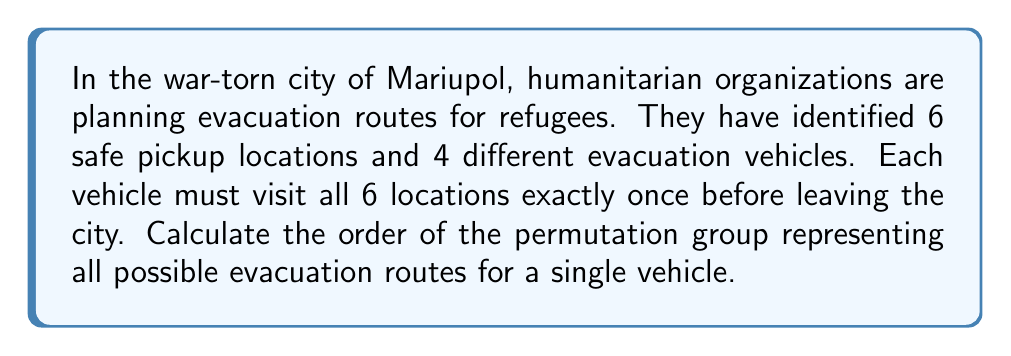Could you help me with this problem? To solve this problem, we need to consider the following steps:

1) The problem describes a permutation of 6 elements (the 6 safe pickup locations).

2) In permutation group theory, the number of possible permutations of $n$ distinct elements is given by $n!$ (n factorial).

3) In this case, $n = 6$, so we need to calculate $6!$.

4) Let's expand this calculation:

   $$6! = 6 \times 5 \times 4 \times 3 \times 2 \times 1$$

5) Multiplying these numbers:

   $$6! = 720$$

6) In group theory, the number of elements in a group is called its order.

7) Therefore, the order of the permutation group representing all possible evacuation routes for a single vehicle is 720.

Note: Each of these 720 permutations represents a unique route that visits all 6 locations exactly once. This large number of possibilities allows for flexibility in planning, which could be crucial in a volatile situation like that in Mariupol.
Answer: The order of the permutation group is 720. 